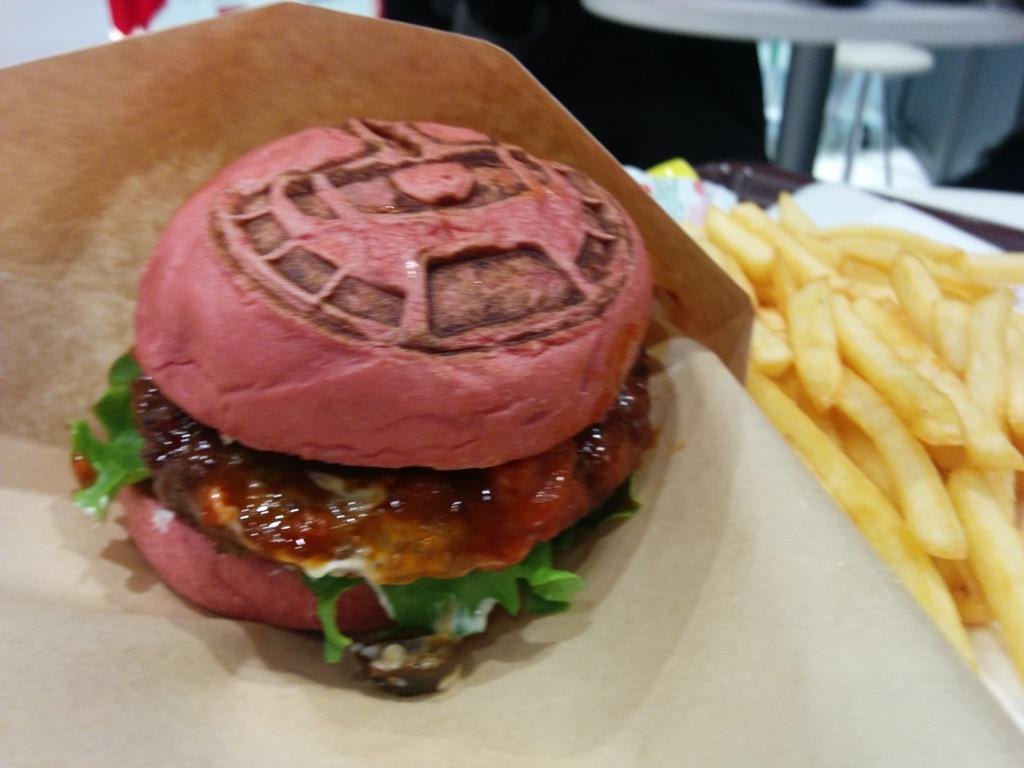What type of food is present in the image? There are french fries in the image. Can you describe the colors of the food in the image? The food in the image has pink, green, white, and red colors. What is the color of the brown-colored object in the image? The brown-colored object in the image is not described in the facts provided. What type of quilt is being sold in the store depicted in the image? There is no store or quilt present in the image; it only features food items. Can you tell me how many pears are visible in the image? There are no pears present in the image. 